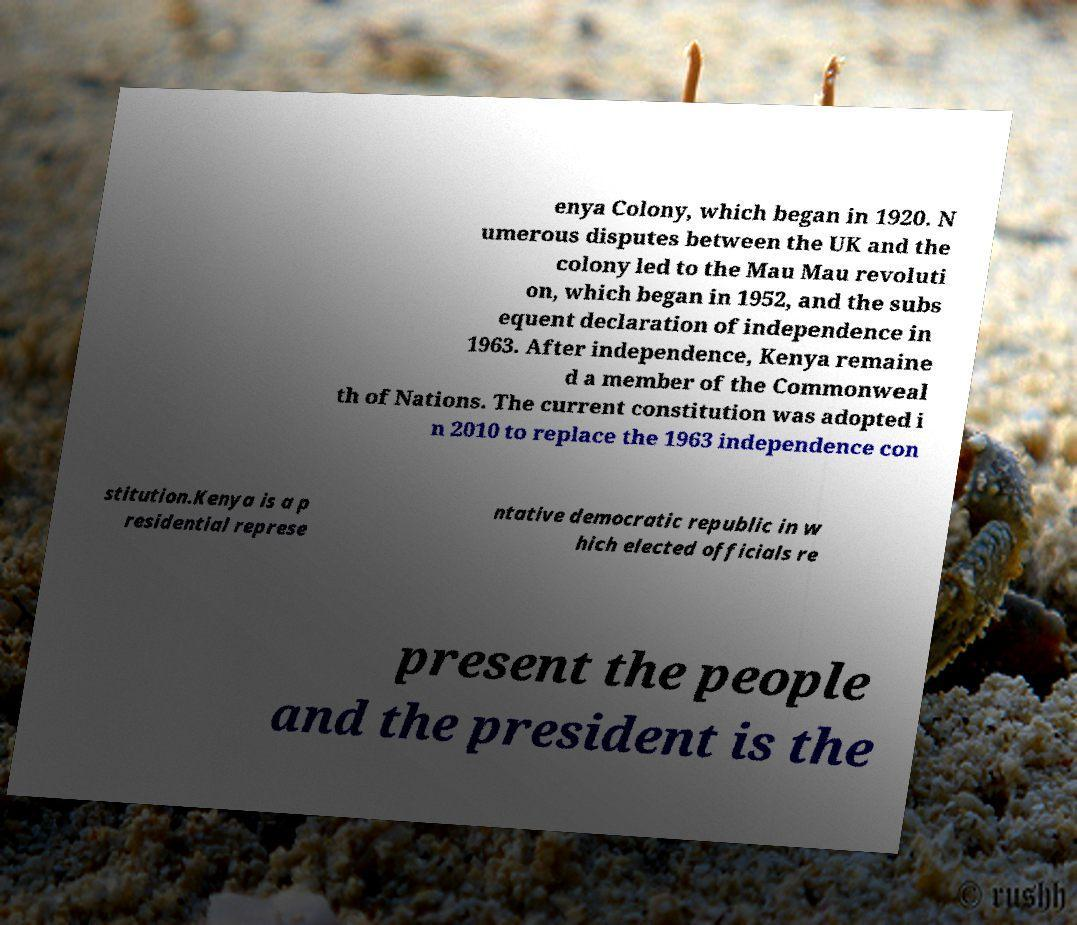Could you extract and type out the text from this image? enya Colony, which began in 1920. N umerous disputes between the UK and the colony led to the Mau Mau revoluti on, which began in 1952, and the subs equent declaration of independence in 1963. After independence, Kenya remaine d a member of the Commonweal th of Nations. The current constitution was adopted i n 2010 to replace the 1963 independence con stitution.Kenya is a p residential represe ntative democratic republic in w hich elected officials re present the people and the president is the 